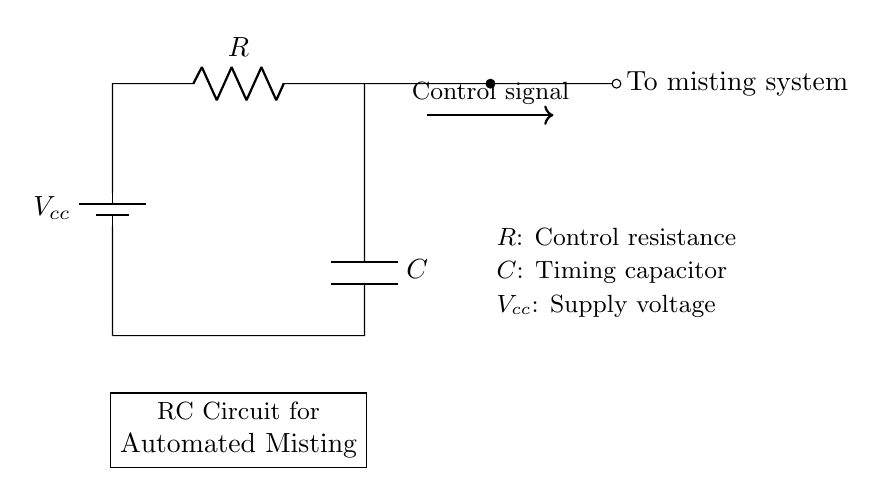What is the control resistance in this circuit? The circuit diagram labels the resistor as "R," which represents control resistance.
Answer: R What is the supply voltage marked in the circuit? The supply voltage is denoted as "Vcc" in the circuit diagram.
Answer: Vcc What component is used for timing in this circuit? The timing component in this circuit is labeled as "C," indicating it is a capacitor.
Answer: C How is the misting system activated in this circuit? The misting system is activated by a control signal, as indicated by the arrow and label in the diagram.
Answer: Control signal What happens to the misting system when the capacitor charges? When the capacitor charges, the voltage across it increases to a certain threshold, allowing the misting system to activate according to the control signal from the resistor-capacitor timing action.
Answer: Activate What is the relationship between resistance and timing in an RC circuit? The timing in an RC circuit is determined by the product of the resistance (R) and capacitance (C), which sets the time constant. Higher resistance leads to longer charging times.
Answer: Time constant What happens if the resistor value is decreased? Decreasing the resistor value will result in a shorter time constant, causing the capacitor to charge faster and the misting system to activate sooner.
Answer: Faster activation 